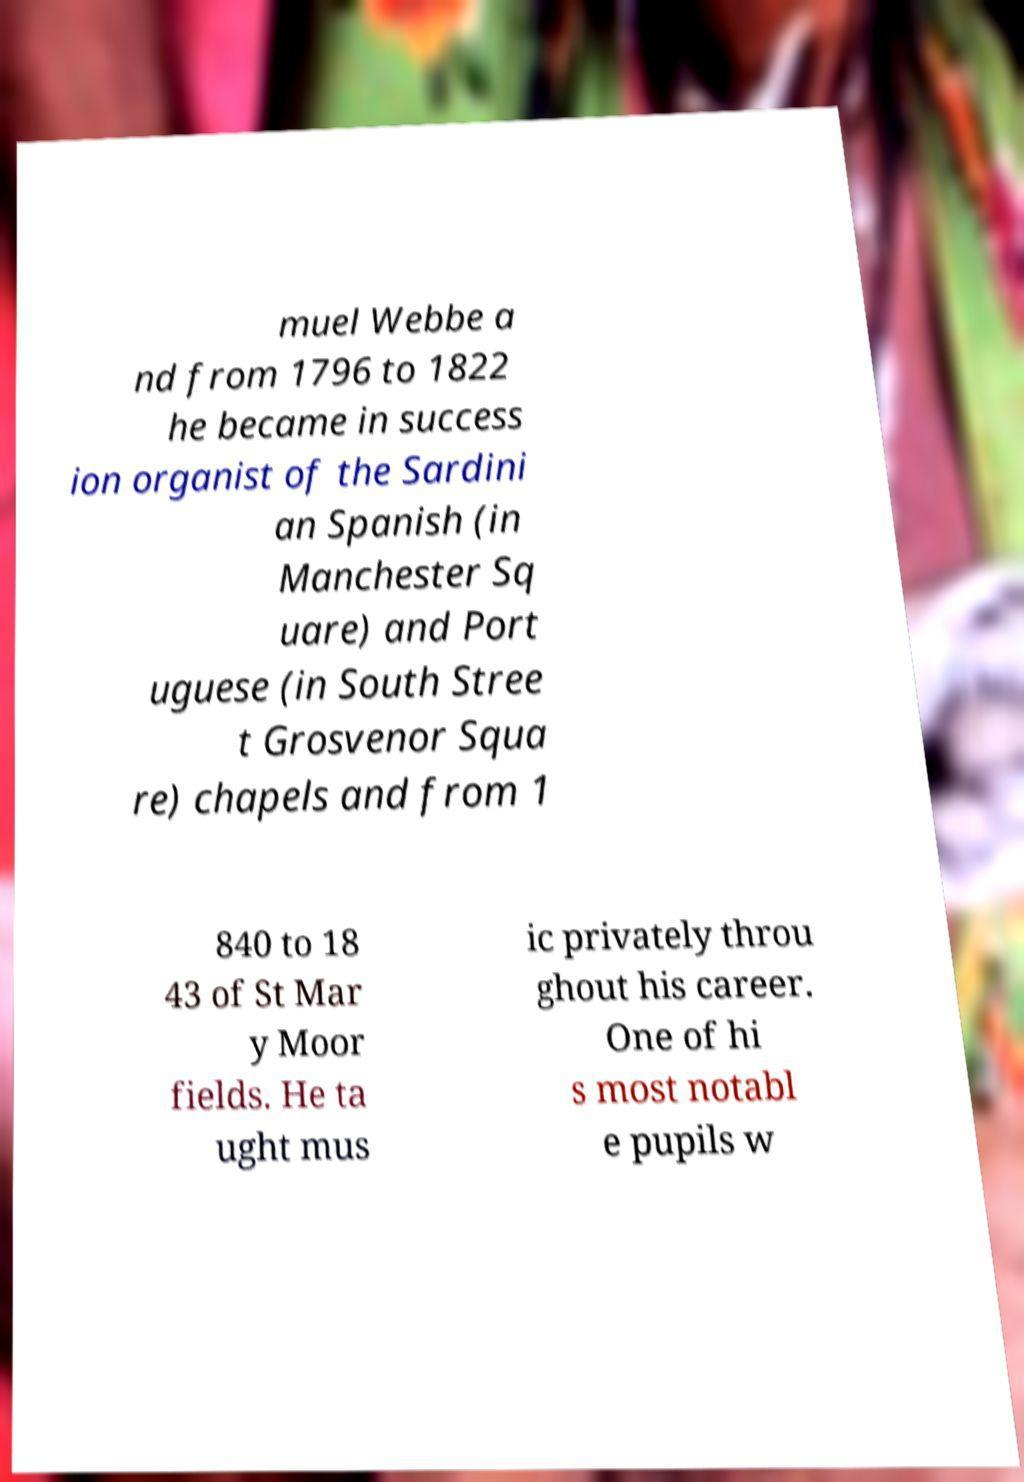Please identify and transcribe the text found in this image. muel Webbe a nd from 1796 to 1822 he became in success ion organist of the Sardini an Spanish (in Manchester Sq uare) and Port uguese (in South Stree t Grosvenor Squa re) chapels and from 1 840 to 18 43 of St Mar y Moor fields. He ta ught mus ic privately throu ghout his career. One of hi s most notabl e pupils w 